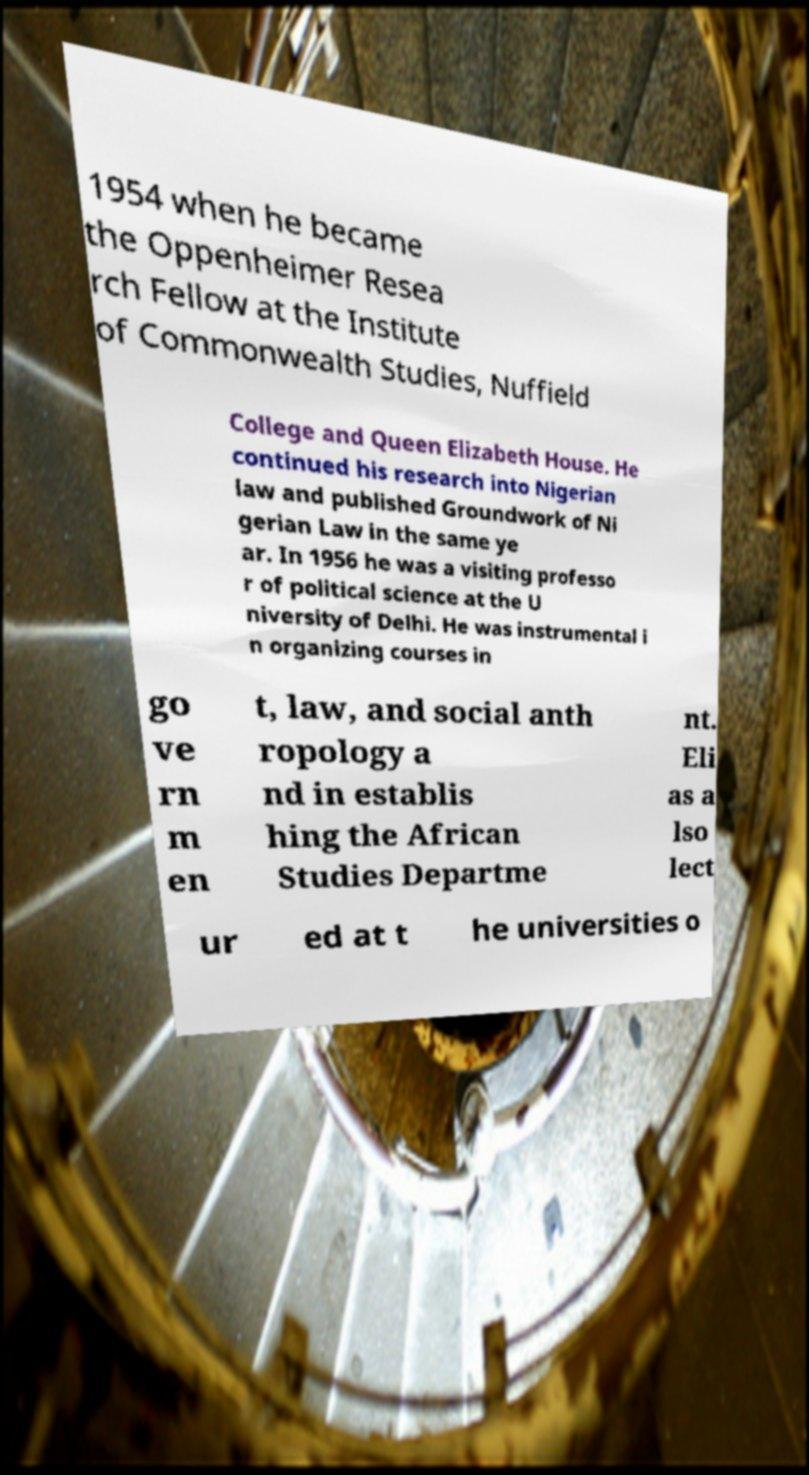What messages or text are displayed in this image? I need them in a readable, typed format. 1954 when he became the Oppenheimer Resea rch Fellow at the Institute of Commonwealth Studies, Nuffield College and Queen Elizabeth House. He continued his research into Nigerian law and published Groundwork of Ni gerian Law in the same ye ar. In 1956 he was a visiting professo r of political science at the U niversity of Delhi. He was instrumental i n organizing courses in go ve rn m en t, law, and social anth ropology a nd in establis hing the African Studies Departme nt. Eli as a lso lect ur ed at t he universities o 